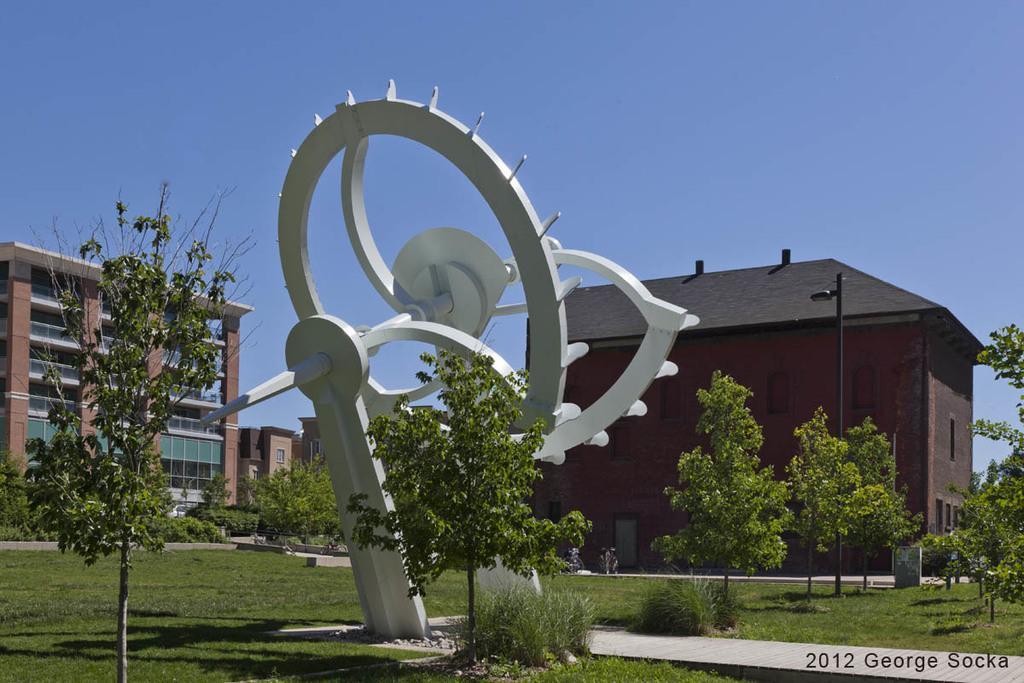In one or two sentences, can you explain what this image depicts? In the center of the image we can see a statue. We can also see a group of plants and grass. On the backside we can see some buildings, a house with roof and windows, a street pole, a board and the sky which looks cloudy. 